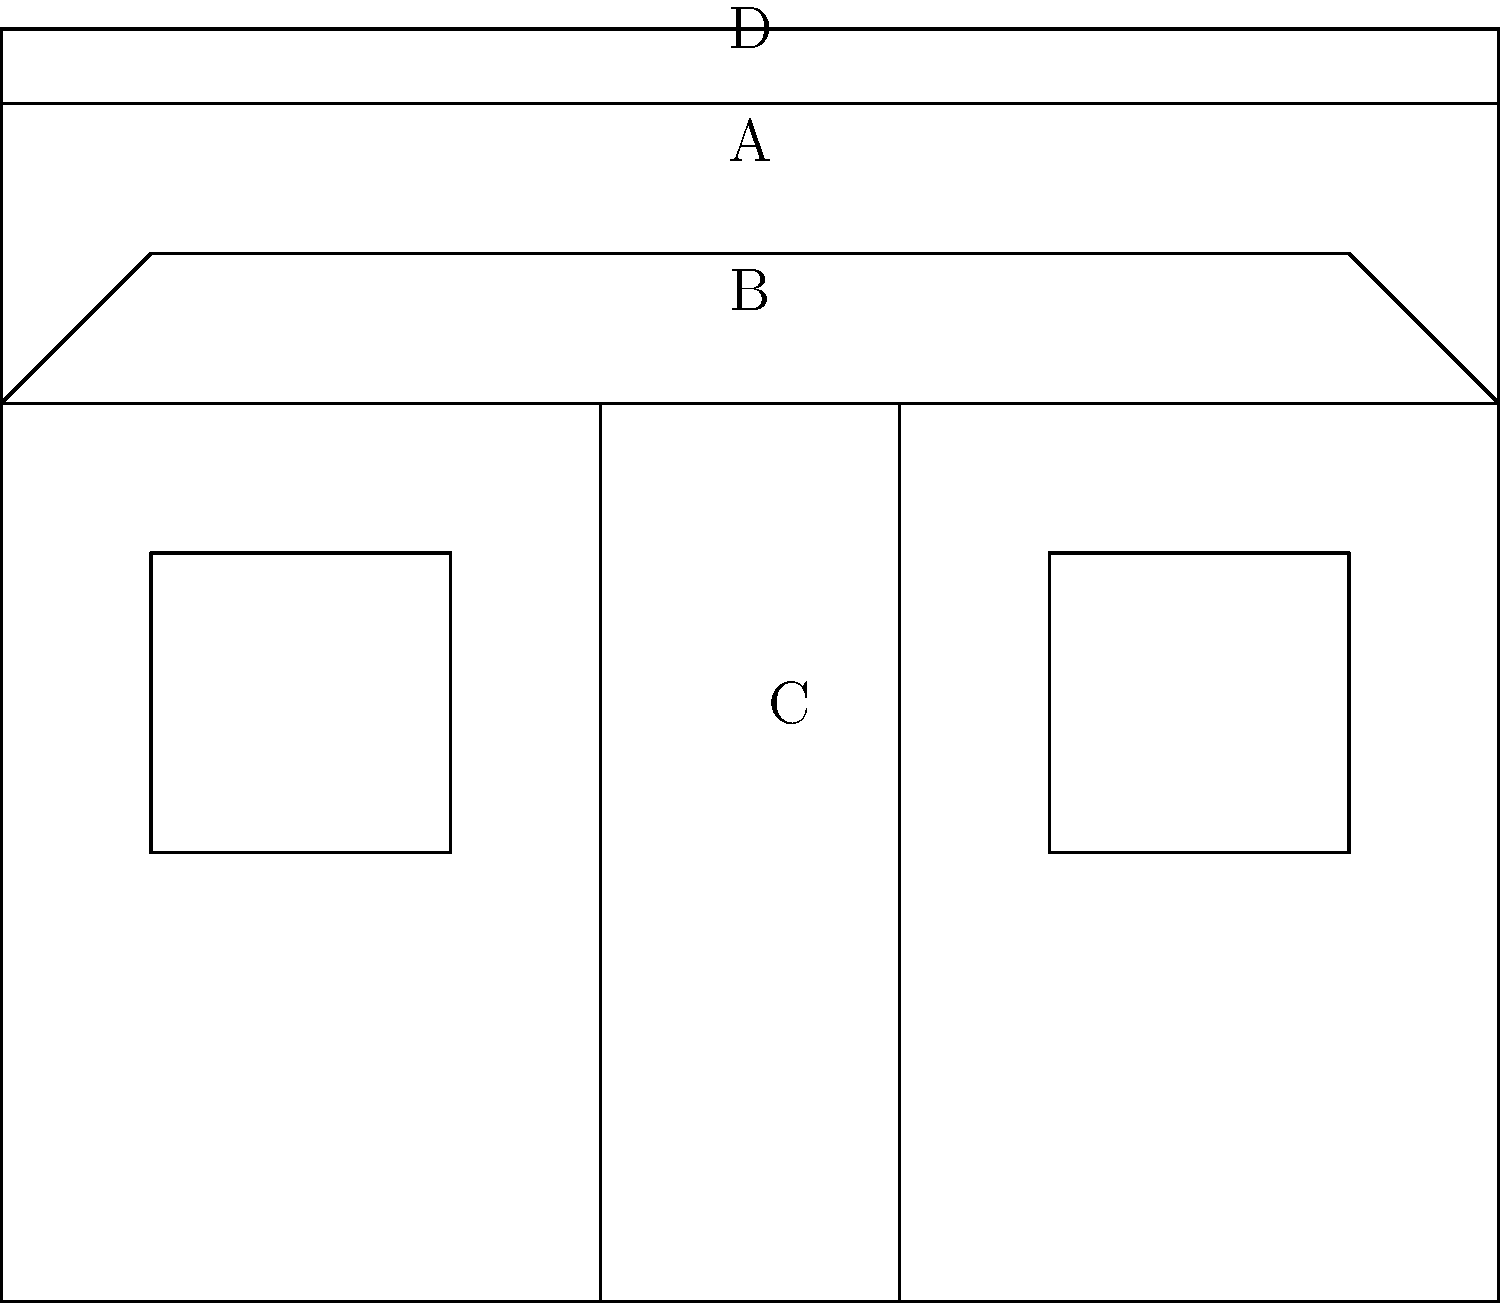In the vintage storefront illustration above, identify the architectural elements labeled A, B, C, and D. Which of these elements typically serves both a functional and decorative purpose in protecting the entrance from weather while adding visual interest to the facade? To answer this question, let's analyze each labeled element in the vintage storefront illustration:

1. Element A: This is the area between the top of the windows/door and the cornice. In architectural terms, this space is called the frieze. It's often used for signage or decorative elements.

2. Element B: This projecting structure above the windows and door is known as an awning. Awnings serve both functional and aesthetic purposes. They protect the entrance and display windows from sun and rain while adding visual interest to the storefront.

3. Element C: These rectangular openings in the facade are windows. In a storefront design, they're typically large display windows used to showcase merchandise and attract customers.

4. Element D: The decorative molding at the top of the facade is called a cornice. It's primarily an ornamental feature that adds visual interest and helps define the top of the building.

Among these elements, the awning (B) is the one that typically serves both a functional and decorative purpose. It protects the entrance and windows from weather elements like sun and rain, making it more comfortable for customers to approach and view displays. At the same time, awnings can be designed in various styles, colors, and materials to enhance the overall aesthetic appeal of the storefront.
Answer: Awning (B) 